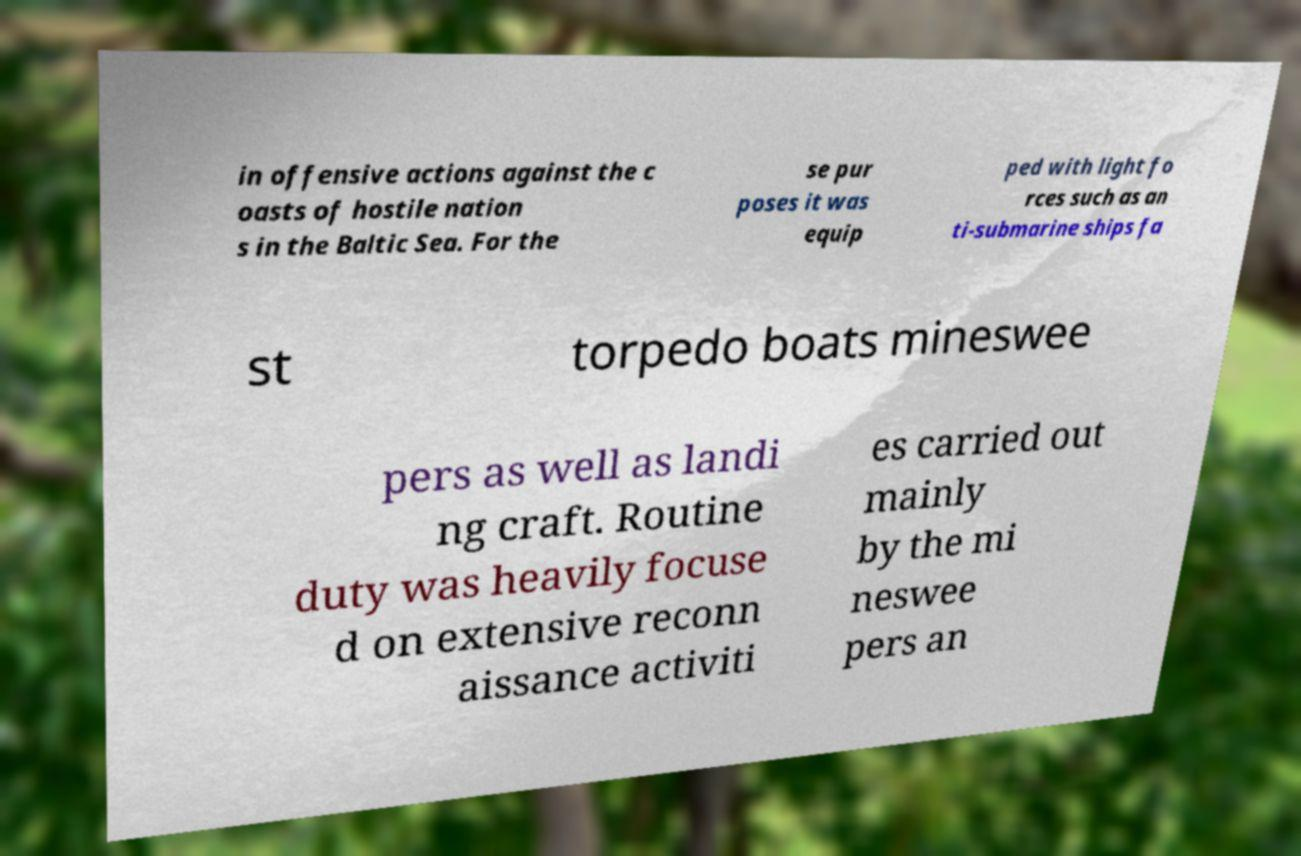Could you extract and type out the text from this image? in offensive actions against the c oasts of hostile nation s in the Baltic Sea. For the se pur poses it was equip ped with light fo rces such as an ti-submarine ships fa st torpedo boats mineswee pers as well as landi ng craft. Routine duty was heavily focuse d on extensive reconn aissance activiti es carried out mainly by the mi neswee pers an 